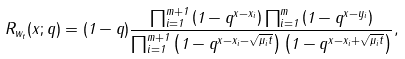<formula> <loc_0><loc_0><loc_500><loc_500>R _ { w _ { t } } ( x ; q ) = ( 1 - q ) \frac { \prod _ { i = 1 } ^ { m + 1 } \left ( 1 - q ^ { x - x _ { i } } \right ) \prod _ { i = 1 } ^ { m } \left ( 1 - q ^ { x - y _ { i } } \right ) } { \prod _ { i = 1 } ^ { m + 1 } \left ( 1 - q ^ { x - x _ { i } - \sqrt { \mu _ { i } t } } \right ) \left ( 1 - q ^ { x - x _ { i } + \sqrt { \mu _ { i } t } } \right ) } ,</formula> 